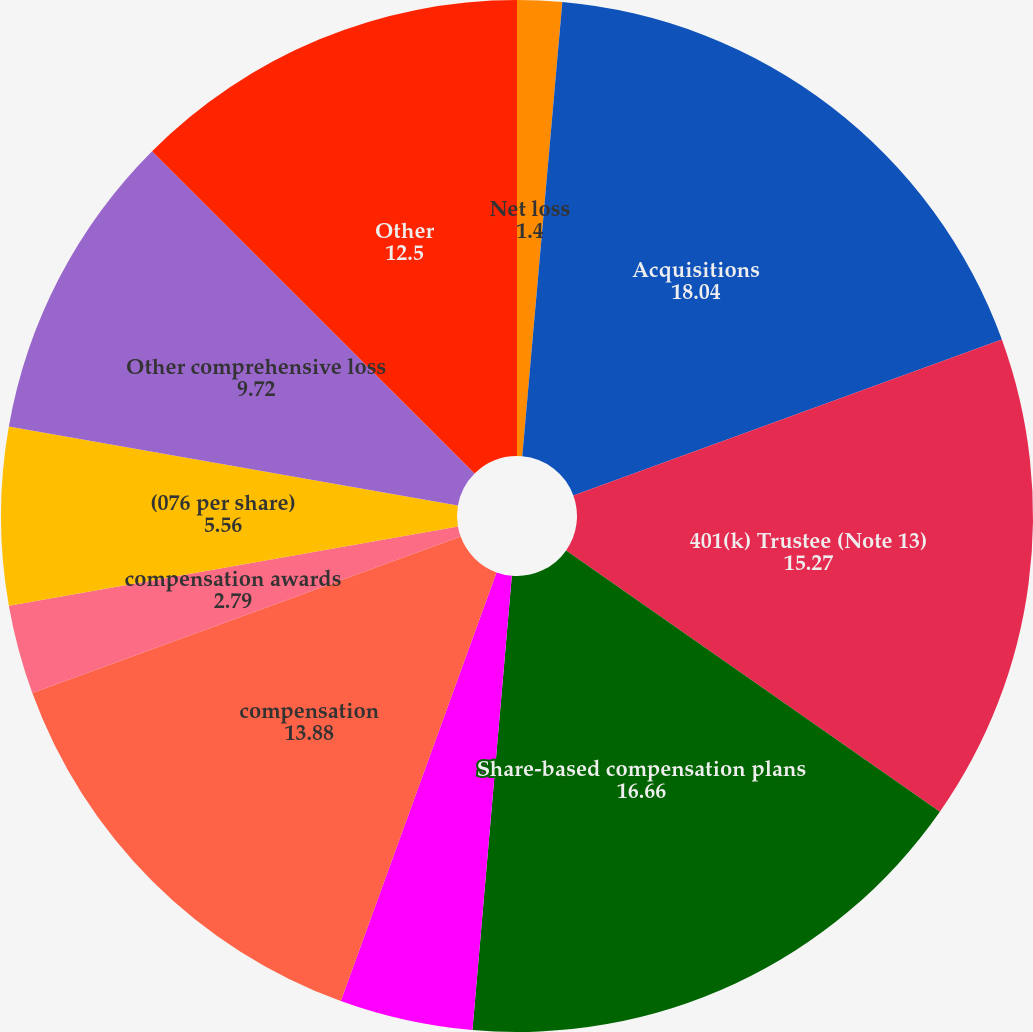Convert chart. <chart><loc_0><loc_0><loc_500><loc_500><pie_chart><fcel>Net loss<fcel>Acquisitions<fcel>401(k) Trustee (Note 13)<fcel>Share-based compensation plans<fcel>Share-based compensation<fcel>compensation<fcel>compensation awards<fcel>(076 per share)<fcel>Other comprehensive loss<fcel>Other<nl><fcel>1.4%<fcel>18.04%<fcel>15.27%<fcel>16.66%<fcel>4.17%<fcel>13.88%<fcel>2.79%<fcel>5.56%<fcel>9.72%<fcel>12.5%<nl></chart> 